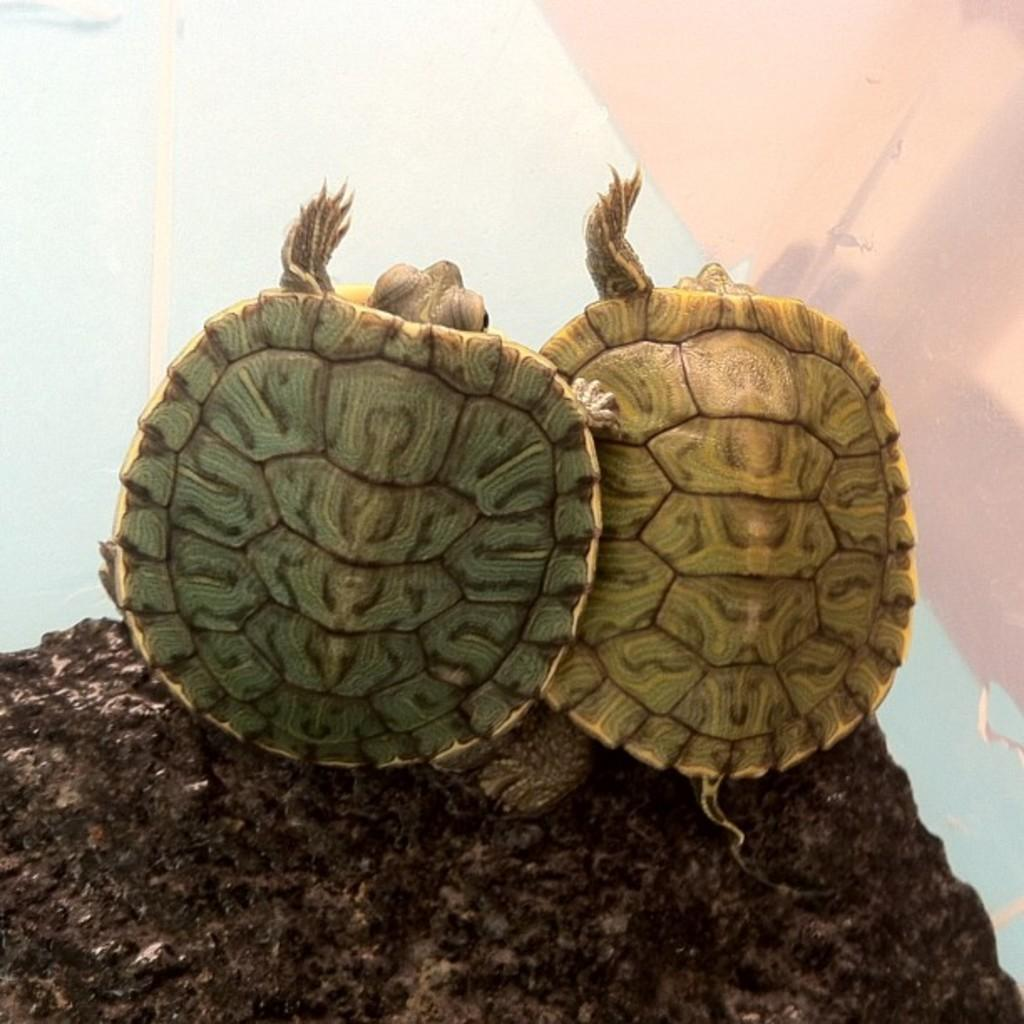What type of animals are on the surface in the image? There are turtles on the surface in the image. What is the price of the kitten in the image? There is no kitten present in the image, so it is not possible to determine its price. 